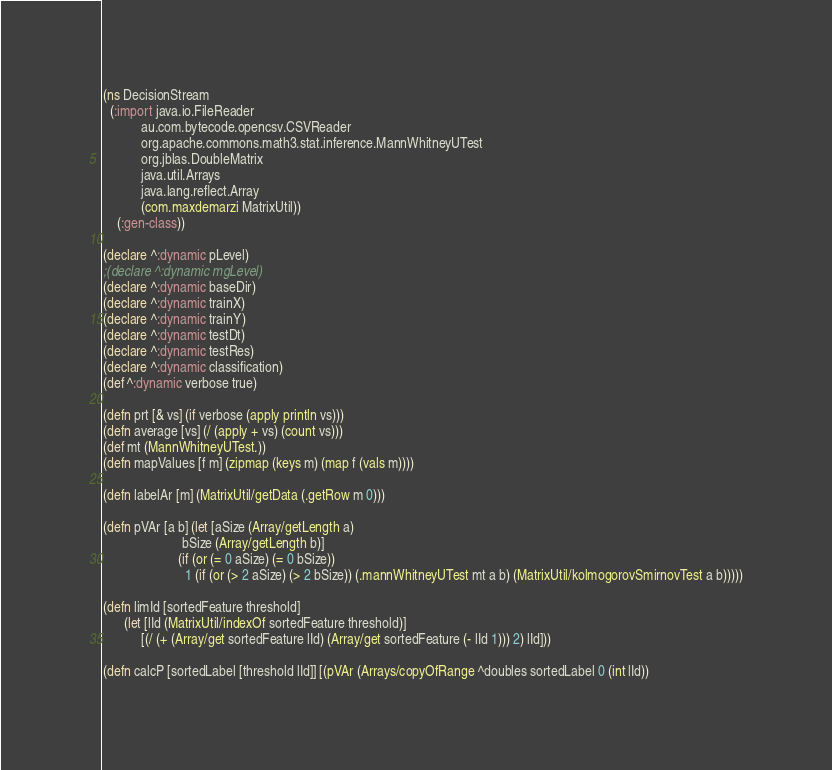Convert code to text. <code><loc_0><loc_0><loc_500><loc_500><_Clojure_>(ns DecisionStream
  (:import java.io.FileReader
           au.com.bytecode.opencsv.CSVReader
           org.apache.commons.math3.stat.inference.MannWhitneyUTest
           org.jblas.DoubleMatrix
           java.util.Arrays
           java.lang.reflect.Array
           (com.maxdemarzi MatrixUtil))
    (:gen-class))

(declare ^:dynamic pLevel)
;(declare ^:dynamic mgLevel)
(declare ^:dynamic baseDir)
(declare ^:dynamic trainX)
(declare ^:dynamic trainY)
(declare ^:dynamic testDt)
(declare ^:dynamic testRes)
(declare ^:dynamic classification)
(def ^:dynamic verbose true)

(defn prt [& vs] (if verbose (apply println vs)))
(defn average [vs] (/ (apply + vs) (count vs)))
(def mt (MannWhitneyUTest.))
(defn mapValues [f m] (zipmap (keys m) (map f (vals m))))

(defn labelAr [m] (MatrixUtil/getData (.getRow m 0)))

(defn pVAr [a b] (let [aSize (Array/getLength a)
                       bSize (Array/getLength b)]
                      (if (or (= 0 aSize) (= 0 bSize))
                        1 (if (or (> 2 aSize) (> 2 bSize)) (.mannWhitneyUTest mt a b) (MatrixUtil/kolmogorovSmirnovTest a b)))))

(defn limId [sortedFeature threshold]
      (let [lId (MatrixUtil/indexOf sortedFeature threshold)]
           [(/ (+ (Array/get sortedFeature lId) (Array/get sortedFeature (- lId 1))) 2) lId]))

(defn calcP [sortedLabel [threshold lId]] [(pVAr (Arrays/copyOfRange ^doubles sortedLabel 0 (int lId))</code> 